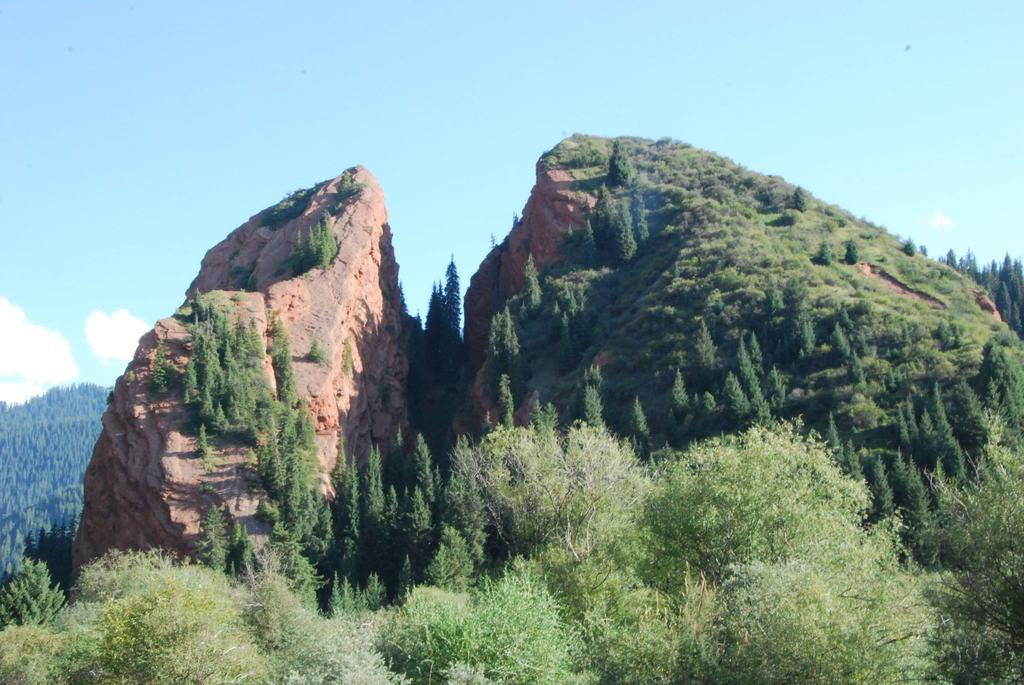What type of landform is present in the image? There is a hill in the image. What is covering part of the hill? The hill is partially covered with greenery. What type of vegetation is present in front of the hill? There is thick grass and plants in front of the hill. What can be seen in the background of the image? The sky is visible in the background of the image. How does the hill express regret in the image? The hill does not express regret in the image, as it is an inanimate object and cannot experience emotions. 